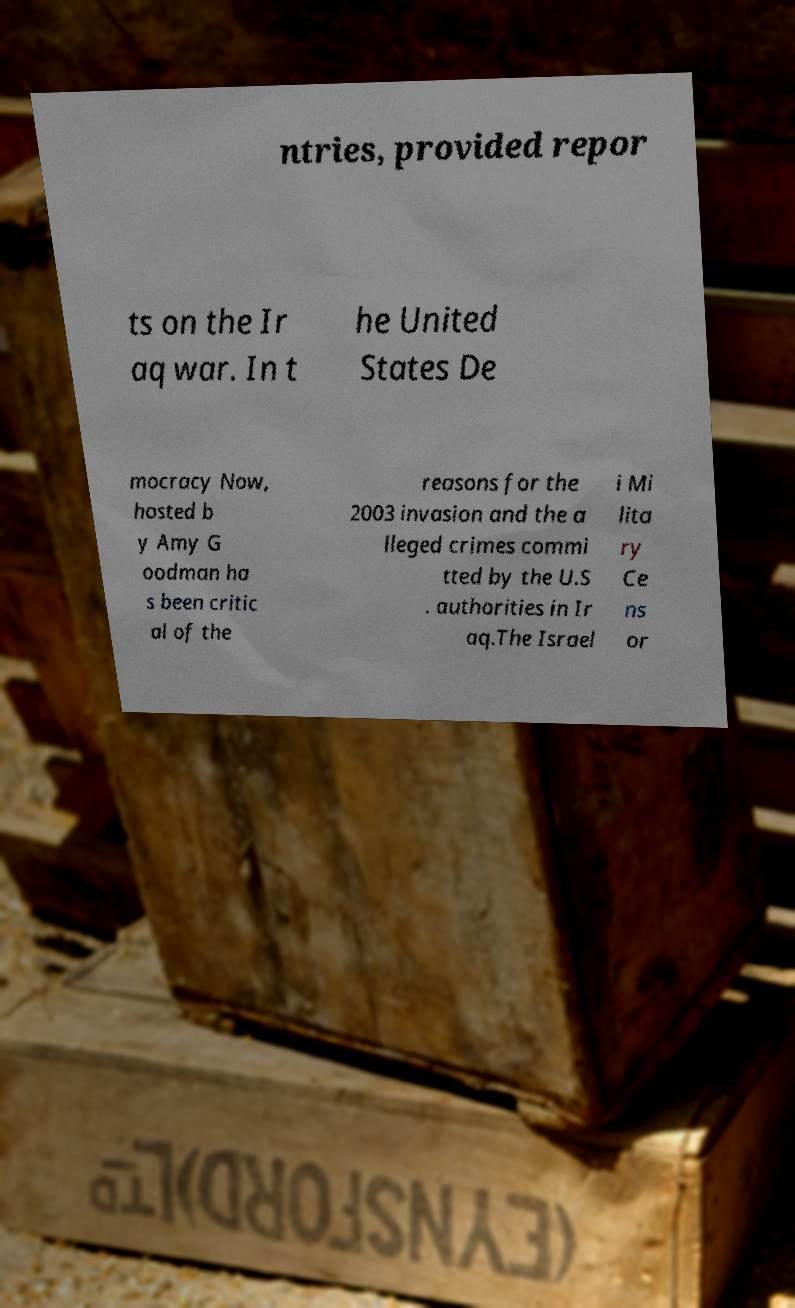Please read and relay the text visible in this image. What does it say? ntries, provided repor ts on the Ir aq war. In t he United States De mocracy Now, hosted b y Amy G oodman ha s been critic al of the reasons for the 2003 invasion and the a lleged crimes commi tted by the U.S . authorities in Ir aq.The Israel i Mi lita ry Ce ns or 